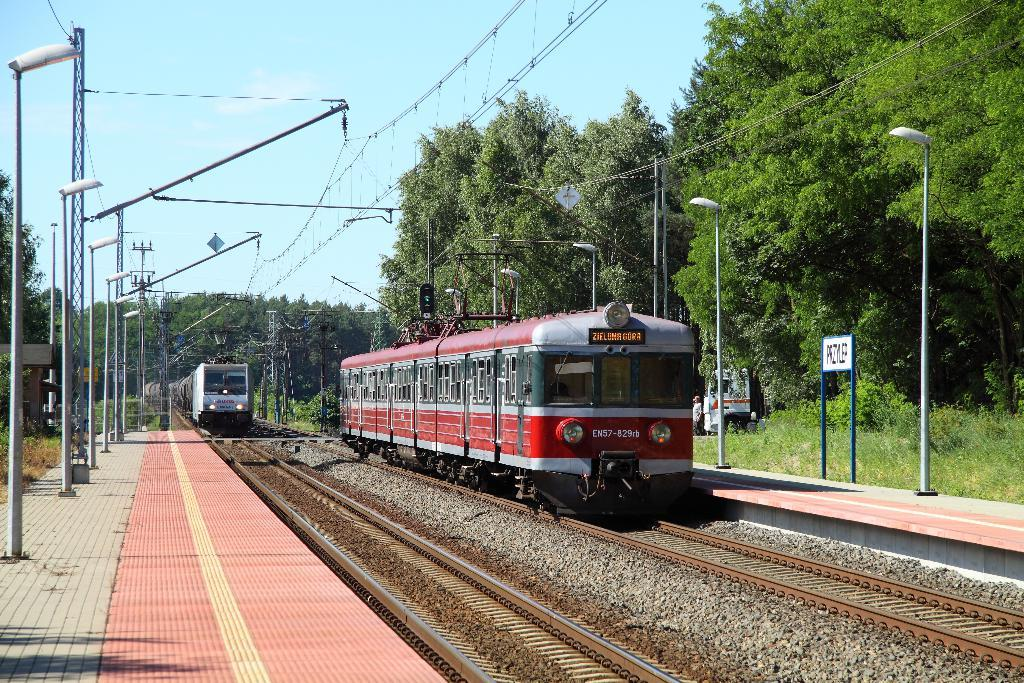What type of vehicles can be seen on the tracks in the image? There are trains on the tracks in the image. What structures are present near the tracks? Electrical poles are visible in the image. What connects the electrical poles? Cables are present in the image. What can be used for illumination in the image? Lights are visible in the image. What is present for passengers to wait and board the trains? There is a platform in the image. What type of natural vegetation is present in the image? Surrounding trees are present in the image. Where is the nest of the bird that is flying in the image? There are no birds or nests present in the image. What type of fuel is used by the trains in the image? The image does not provide information about the type of fuel used by the trains. 